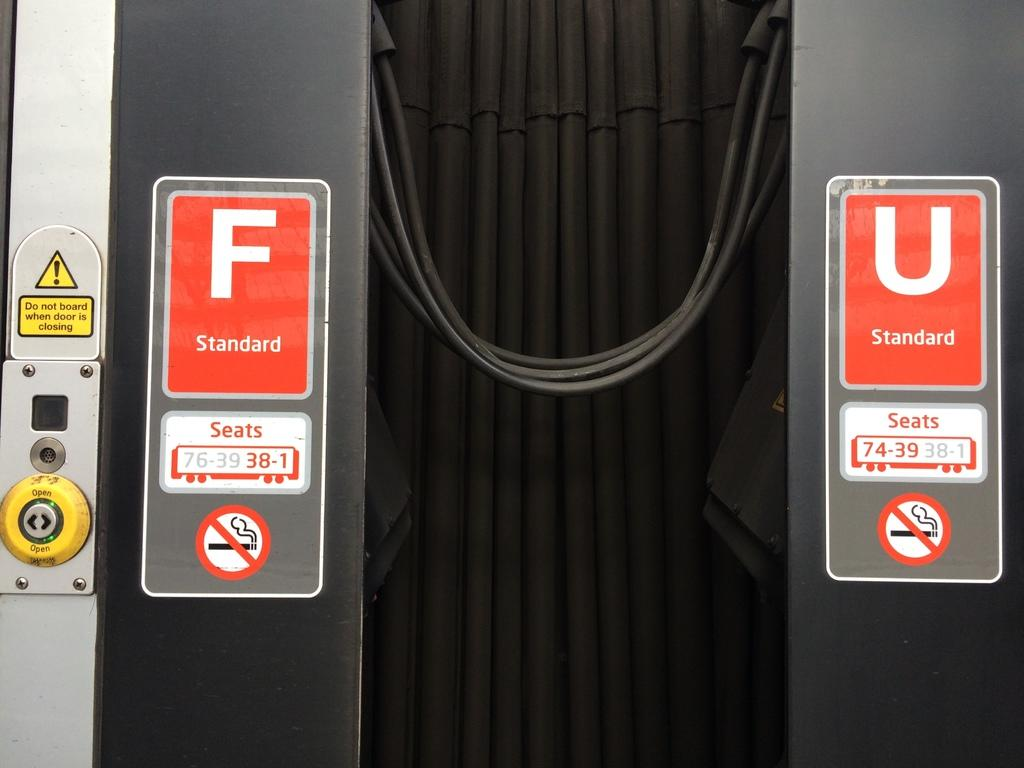What is the main subject of the image? The main subject of the image appears to be an elevator. What can be found on the left side of the elevator? There are buttons on the left side of the elevator. Are there any additional features or markings in the image? Yes, there are red color stickers in the middle of the image, one on each side. How many clocks are hanging on the walls of the elevator? There are no clocks visible in the image; it only shows an elevator with buttons and red color stickers. What type of friction is present between the elevator and the floor? The image does not provide information about the friction between the elevator and the floor, as it only shows the interior of the elevator. 